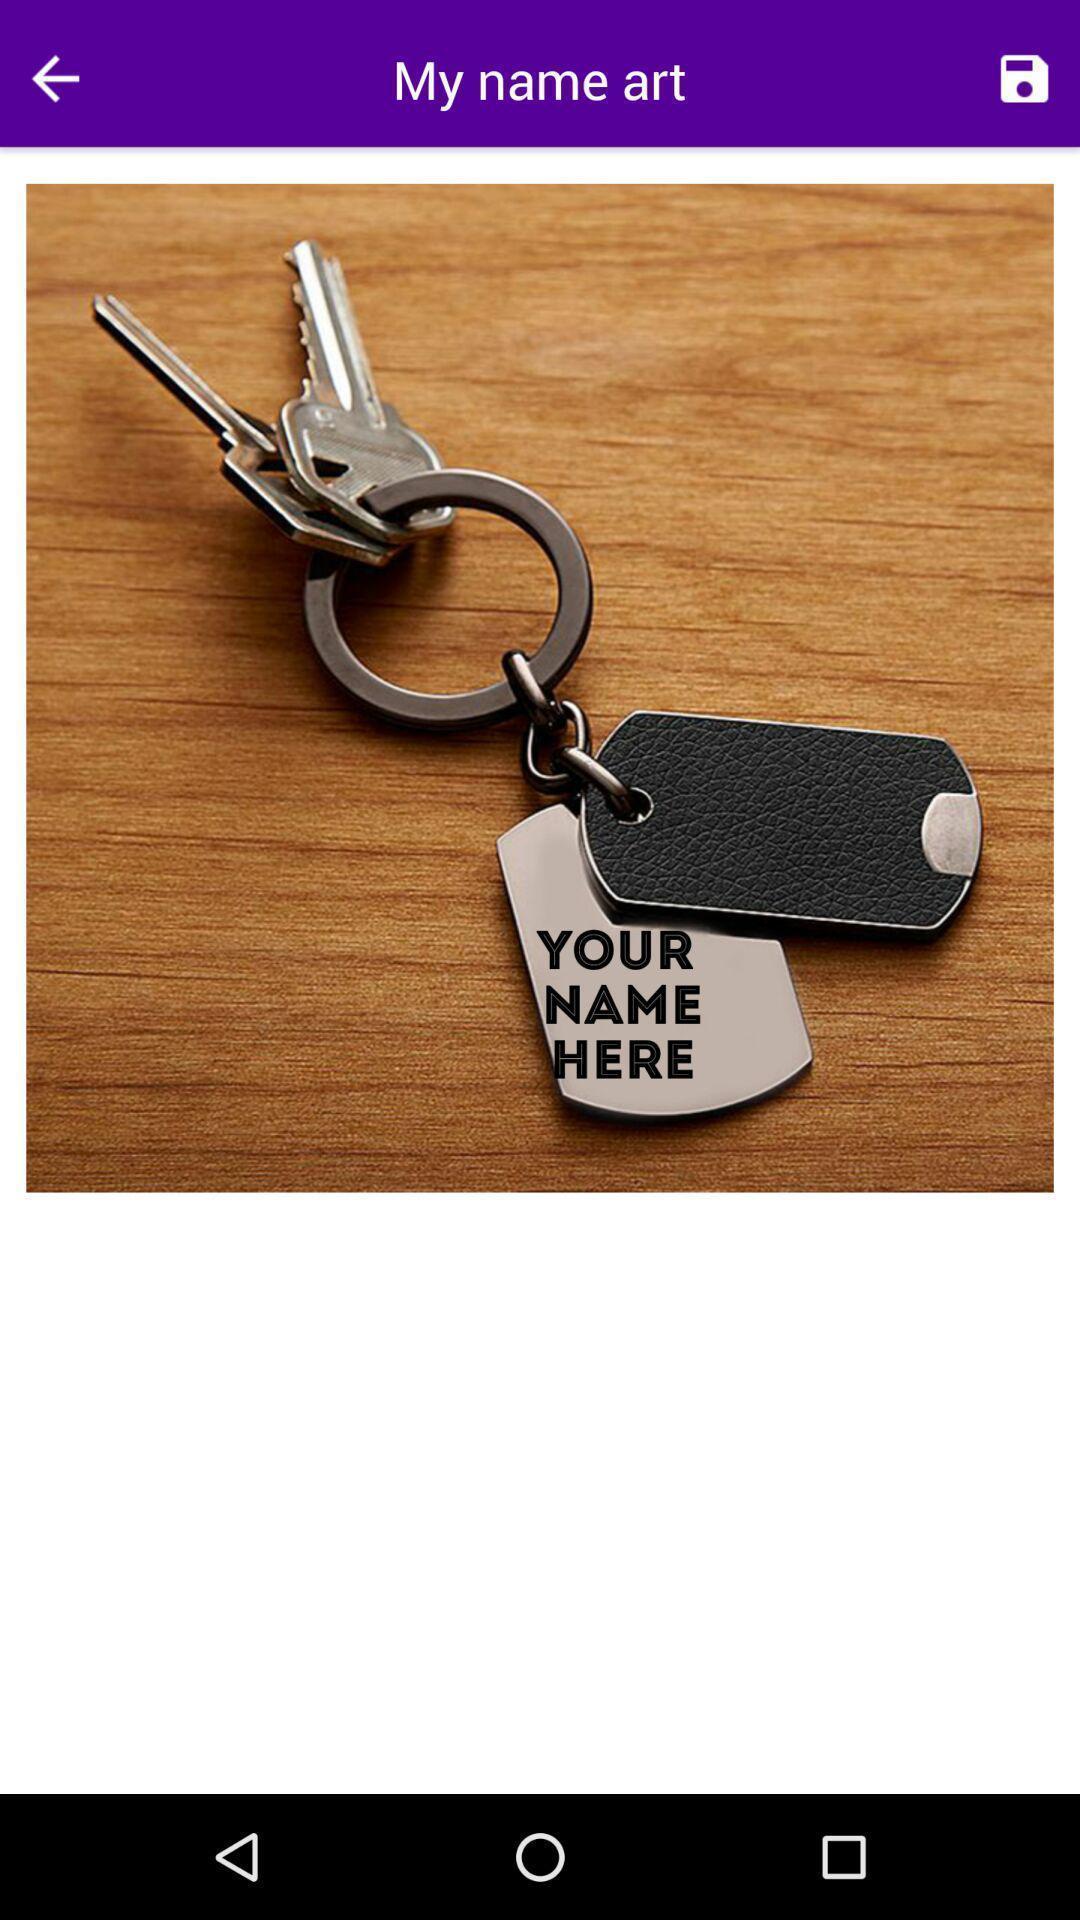Tell me about the visual elements in this screen capture. Screen shows an image with keys. 